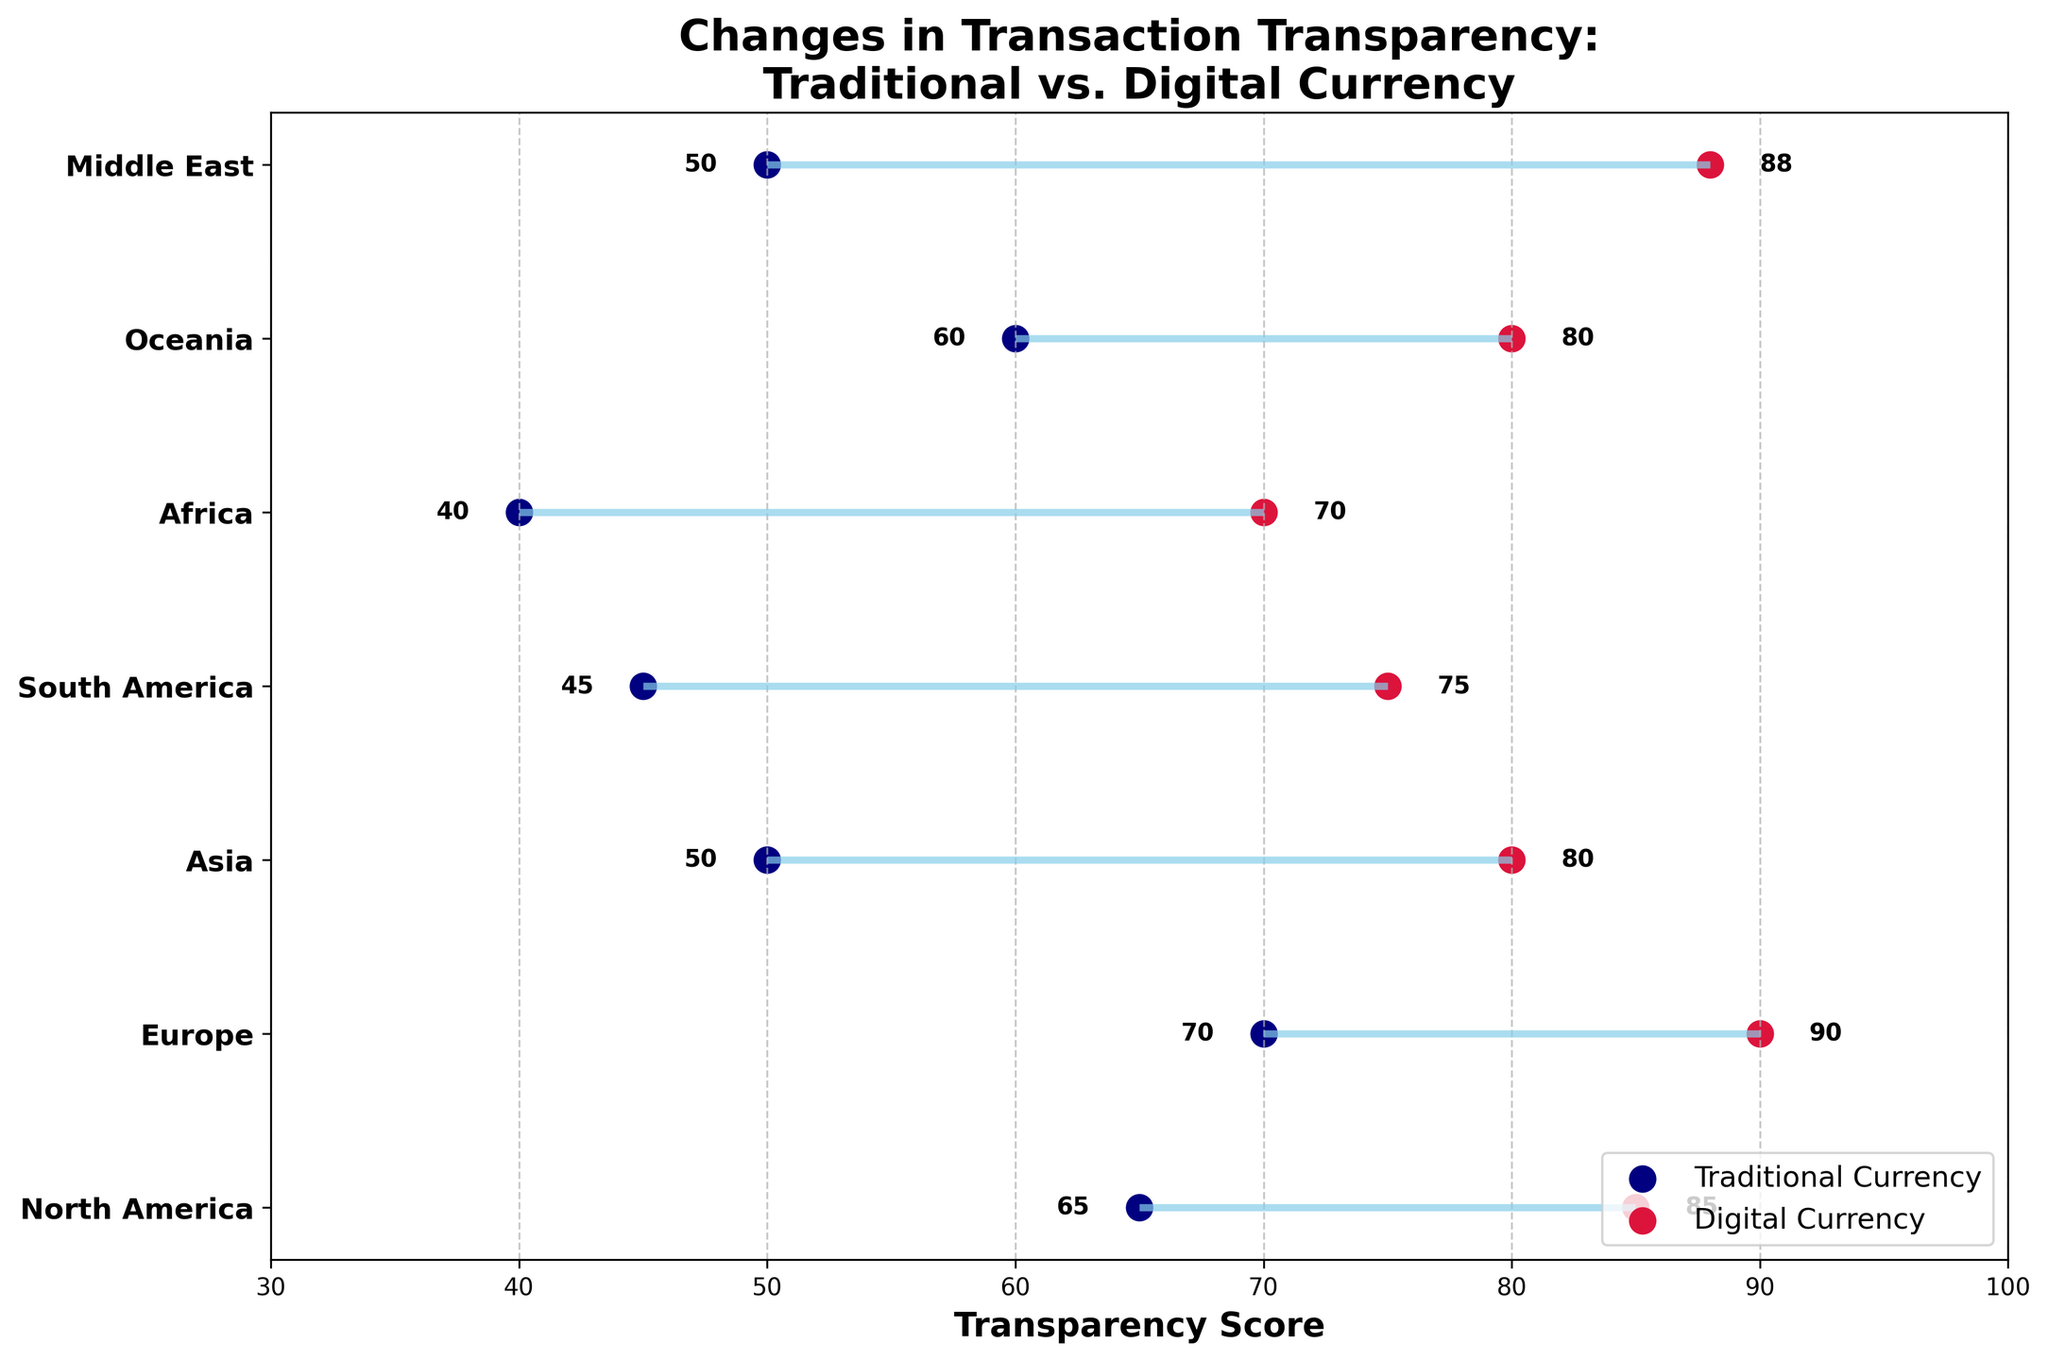What's the title of the plot? The title of the plot is displayed at the top, reading: "Changes in Transaction Transparency: Traditional vs. Digital Currency".
Answer: "Changes in Transaction Transparency: Traditional vs. Digital Currency" What's the transparency score for traditional currency in Europe? Find Europe on the y-axis and look for the traditional currency point, labeled with the score. It shows 70.
Answer: 70 What is the difference in transparency scores between traditional and digital currencies in Asia? Find the points for Asia on the y-axis, noting the values for traditional (50) and digital (80). Subtract the traditional score from the digital score: 80 - 50 = 30.
Answer: 30 Which region shows the greatest improvement in transparency score when switching to digital currency? Find the differences between the traditional and digital currency transparency scores for all regions. The Middle East has the highest difference: 50 (traditional) to 88 (digital), an improvement of 38.
Answer: Middle East Which region has the smallest gap in transparency scores between traditional and digital currencies? Identify the differences between both scores for each region. North America has the smallest gap: 65 (traditional) to 85 (digital), a difference of 20.
Answer: North America What is the average transparency score of digital currencies across all regions? Add up the digital transparency scores for all regions (85 + 90 + 80 + 75 + 70 + 80 + 88) and divide by the number of regions (7). Total is 568, so the average is 568/7 ≈ 81.14.
Answer: 81.14 By how much does digital currency transparency in Oceania exceed that of traditional currency? Locate Oceania and compare the values for traditional (60) and digital (80). Calculate the difference: 80 - 60 = 20.
Answer: 20 How many regions have a digital transparency score greater than 85? Count the regions with a digital transparency score higher than 85. North America (85), Europe (90), Middle East (88) count as 3.
Answer: 3 What is the median transparency score for traditional currency across the regions? Arrange the traditional scores (40, 45, 50, 50, 60, 65, 70) in ascending order. The median is the fourth score: 50.
Answer: 50 